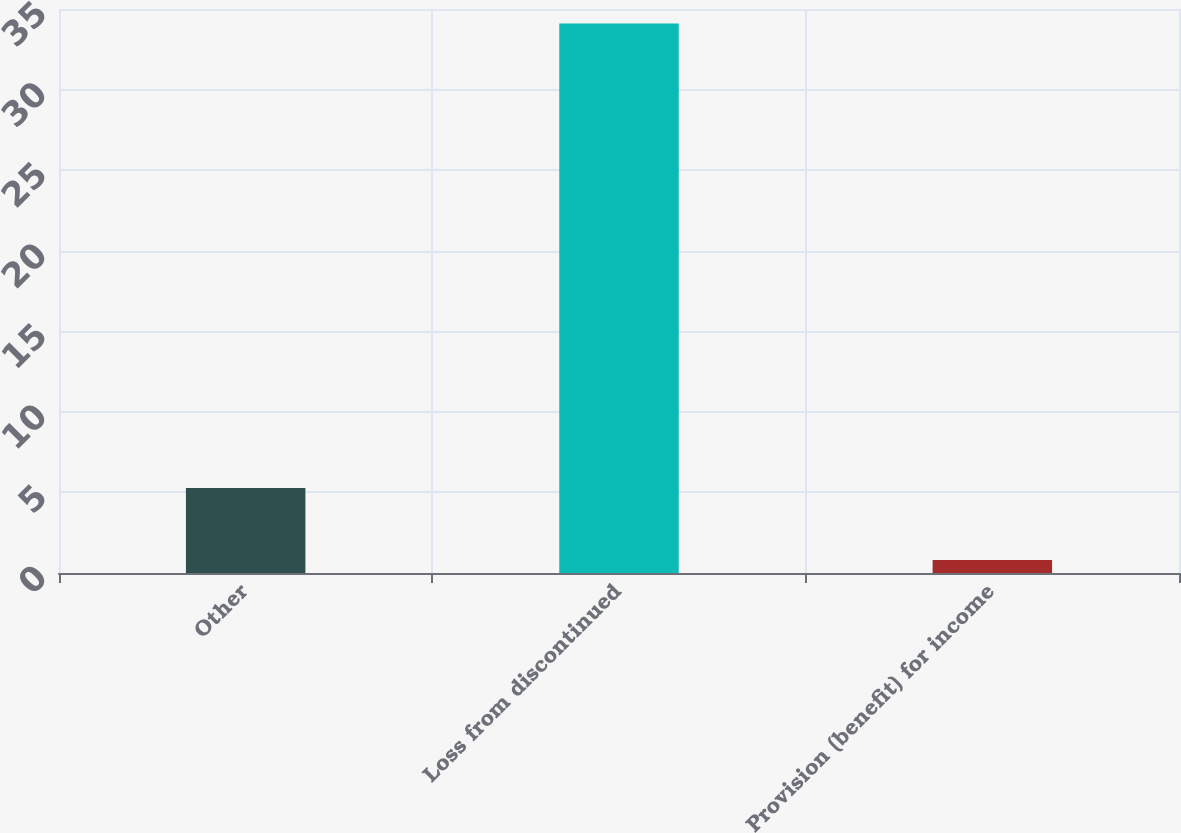Convert chart to OTSL. <chart><loc_0><loc_0><loc_500><loc_500><bar_chart><fcel>Other<fcel>Loss from discontinued<fcel>Provision (benefit) for income<nl><fcel>5.27<fcel>34.1<fcel>0.8<nl></chart> 